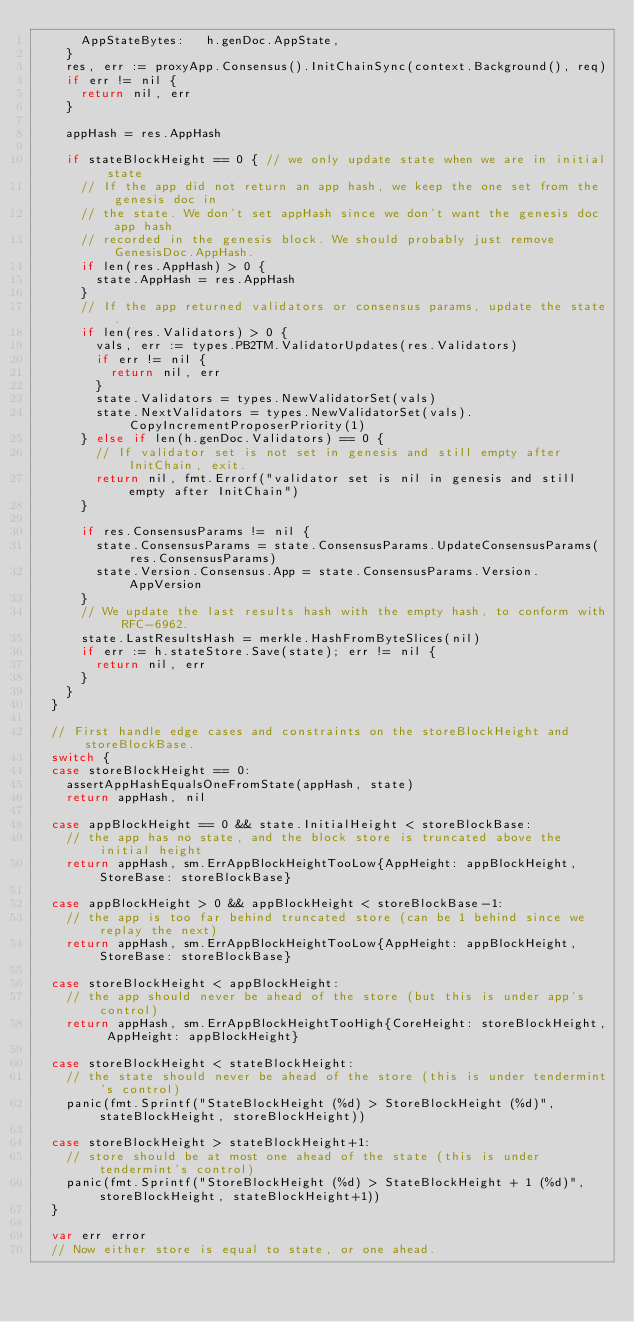Convert code to text. <code><loc_0><loc_0><loc_500><loc_500><_Go_>			AppStateBytes:   h.genDoc.AppState,
		}
		res, err := proxyApp.Consensus().InitChainSync(context.Background(), req)
		if err != nil {
			return nil, err
		}

		appHash = res.AppHash

		if stateBlockHeight == 0 { // we only update state when we are in initial state
			// If the app did not return an app hash, we keep the one set from the genesis doc in
			// the state. We don't set appHash since we don't want the genesis doc app hash
			// recorded in the genesis block. We should probably just remove GenesisDoc.AppHash.
			if len(res.AppHash) > 0 {
				state.AppHash = res.AppHash
			}
			// If the app returned validators or consensus params, update the state.
			if len(res.Validators) > 0 {
				vals, err := types.PB2TM.ValidatorUpdates(res.Validators)
				if err != nil {
					return nil, err
				}
				state.Validators = types.NewValidatorSet(vals)
				state.NextValidators = types.NewValidatorSet(vals).CopyIncrementProposerPriority(1)
			} else if len(h.genDoc.Validators) == 0 {
				// If validator set is not set in genesis and still empty after InitChain, exit.
				return nil, fmt.Errorf("validator set is nil in genesis and still empty after InitChain")
			}

			if res.ConsensusParams != nil {
				state.ConsensusParams = state.ConsensusParams.UpdateConsensusParams(res.ConsensusParams)
				state.Version.Consensus.App = state.ConsensusParams.Version.AppVersion
			}
			// We update the last results hash with the empty hash, to conform with RFC-6962.
			state.LastResultsHash = merkle.HashFromByteSlices(nil)
			if err := h.stateStore.Save(state); err != nil {
				return nil, err
			}
		}
	}

	// First handle edge cases and constraints on the storeBlockHeight and storeBlockBase.
	switch {
	case storeBlockHeight == 0:
		assertAppHashEqualsOneFromState(appHash, state)
		return appHash, nil

	case appBlockHeight == 0 && state.InitialHeight < storeBlockBase:
		// the app has no state, and the block store is truncated above the initial height
		return appHash, sm.ErrAppBlockHeightTooLow{AppHeight: appBlockHeight, StoreBase: storeBlockBase}

	case appBlockHeight > 0 && appBlockHeight < storeBlockBase-1:
		// the app is too far behind truncated store (can be 1 behind since we replay the next)
		return appHash, sm.ErrAppBlockHeightTooLow{AppHeight: appBlockHeight, StoreBase: storeBlockBase}

	case storeBlockHeight < appBlockHeight:
		// the app should never be ahead of the store (but this is under app's control)
		return appHash, sm.ErrAppBlockHeightTooHigh{CoreHeight: storeBlockHeight, AppHeight: appBlockHeight}

	case storeBlockHeight < stateBlockHeight:
		// the state should never be ahead of the store (this is under tendermint's control)
		panic(fmt.Sprintf("StateBlockHeight (%d) > StoreBlockHeight (%d)", stateBlockHeight, storeBlockHeight))

	case storeBlockHeight > stateBlockHeight+1:
		// store should be at most one ahead of the state (this is under tendermint's control)
		panic(fmt.Sprintf("StoreBlockHeight (%d) > StateBlockHeight + 1 (%d)", storeBlockHeight, stateBlockHeight+1))
	}

	var err error
	// Now either store is equal to state, or one ahead.</code> 